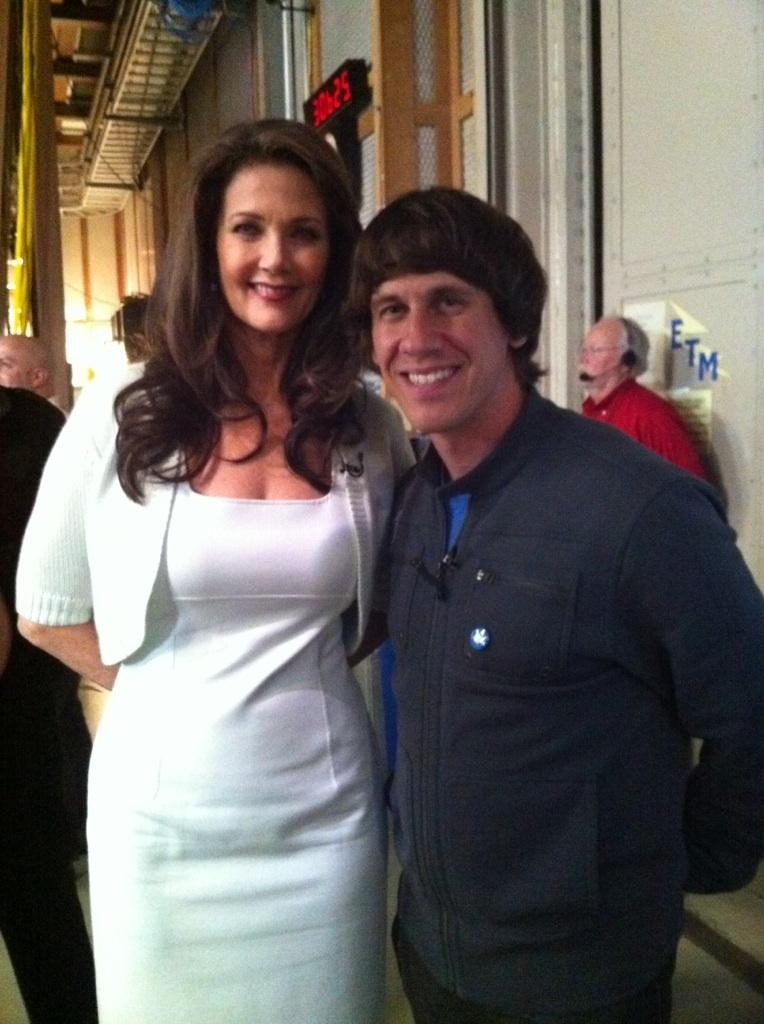What are the two main subjects in the image? There is a woman in a white dress and a man in a black dress in the image. How are the woman and man positioned in relation to each other? The woman is standing beside the man. Are there any other people visible in the image? Yes, there are people standing behind the woman and man. What can be seen on the right side of the image? There is a wall on the right side of the image. What type of knot is being used to hold the wall together in the image? There is no knot visible in the image, as it is a wall and not a rope or fabric. 